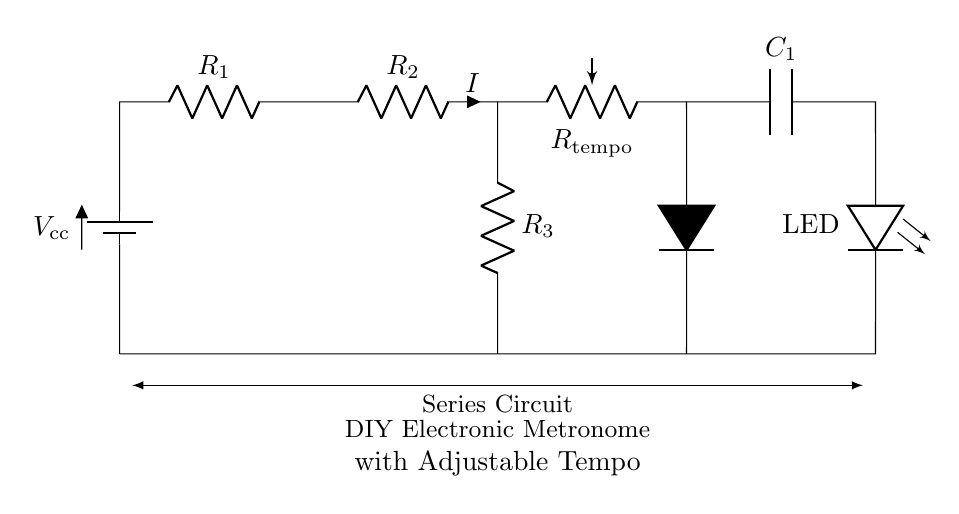What is the total number of resistors in this circuit? There are three resistors in the circuit diagram, labeled as R1, R2, and R3. Each of these components is clearly marked, and counting them gives a total of three.
Answer: Three What is the purpose of the potentiometer in this circuit? The potentiometer, labeled as R_tempo, is used to adjust the tempo of the metronome by varying its resistance. This adjustment influences the timing of the LED blinking, allowing for different beats per minute.
Answer: Tempo adjustment What component would you use to visualize the output? The LED (light-emitting diode) in the circuit indicates the output visually. It lights up when current flows through the circuit, allowing users to see the metronome's beats.
Answer: LED What is the role of the capacitor in the circuit? The capacitor (labeled as C1) helps to control the timing of the circuit by charging and discharging, which affects the blinking rate of the LED and thus the tempo of the metronome.
Answer: Timing control What happens if you increase the value of R_tempo? Increasing the resistance of R_tempo will slow down the rate at which the capacitor charges and discharges, leading to a slower blink rate of the LED. This results in a slower tempo of the metronome.
Answer: Slower tempo What type of circuit is this diagram depicting? The circuit depicted is a series circuit where all components are connected in a single path, meaning the same current flows through each component sequentially.
Answer: Series circuit What is the direction of current flow in the circuit? The current flows from the positive terminal of the battery, through R1, R2, R_tempo, C1, and then to the LED, creating a complete loop back to the negative terminal of the battery.
Answer: Clockwise 